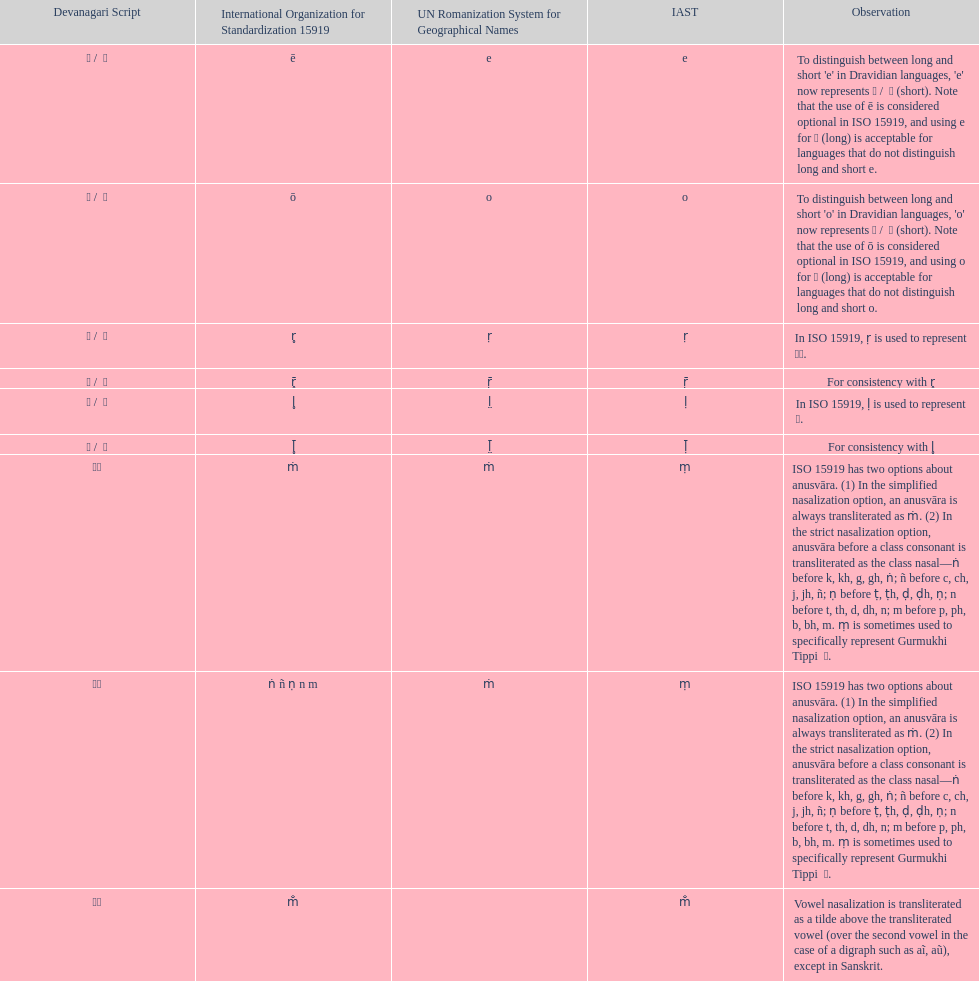What unrsgn is listed previous to the o? E. 